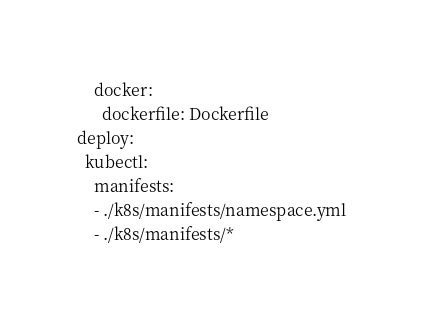<code> <loc_0><loc_0><loc_500><loc_500><_YAML_>    docker:
      dockerfile: Dockerfile
deploy:
  kubectl:
    manifests:
    - ./k8s/manifests/namespace.yml
    - ./k8s/manifests/*</code> 